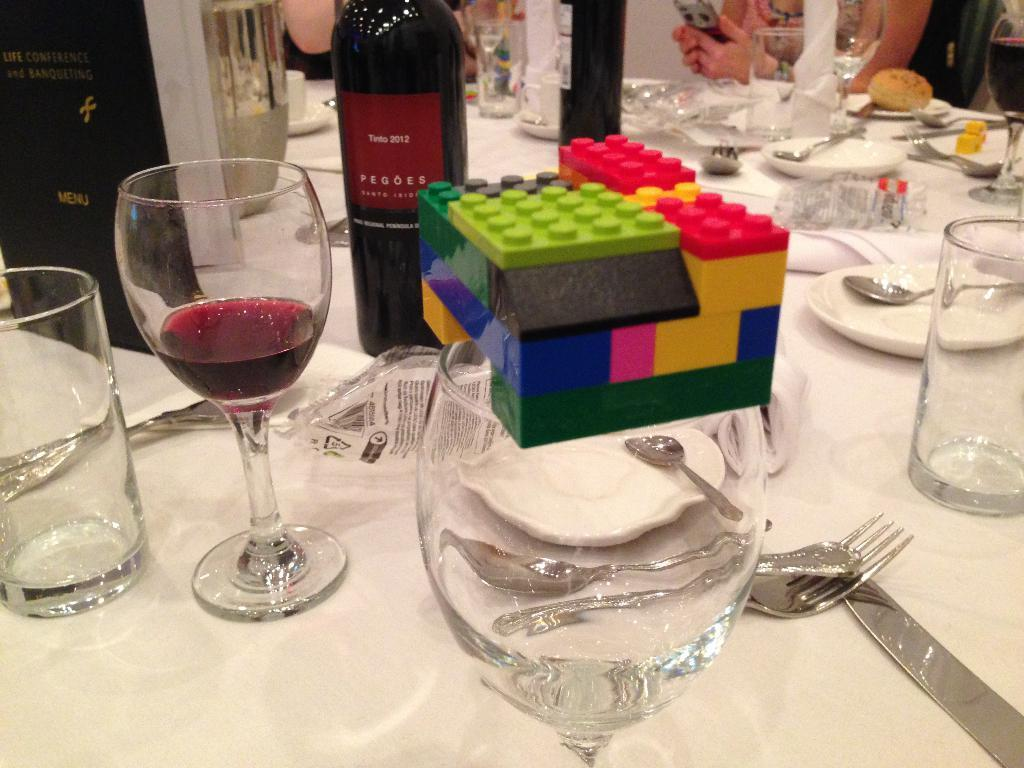What type of furniture is present in the image? There is a table in the image. What items can be seen on the table? There are glasses, bottles, plates, spoons, and blocks on the table. How many types of objects are present on the table? There are five types of objects on the table: glasses, bottles, plates, spoons, and blocks. Are there any people in the image? Yes, there are persons in the image. What type of treatment is being administered to the straw in the image? There is no straw present in the image, so no treatment can be administered to it. 